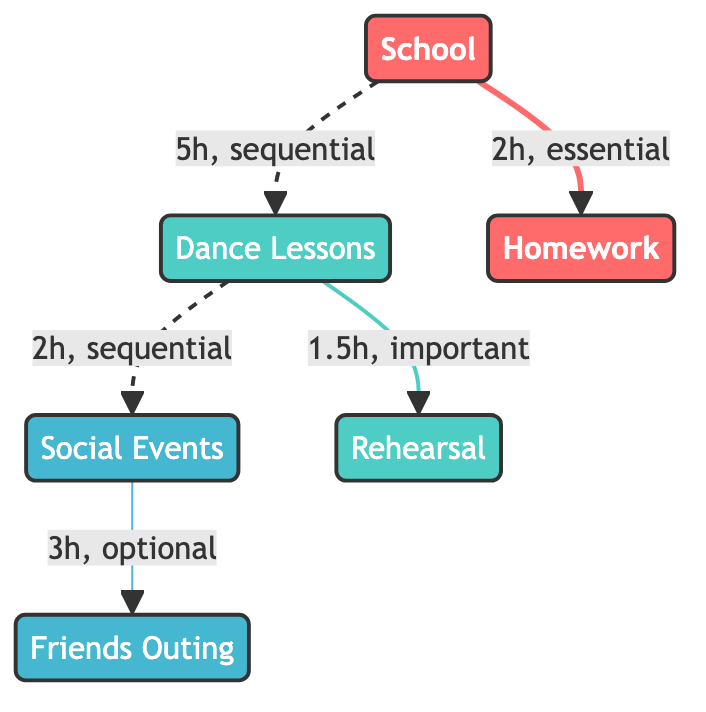What is the priority level of School? The priority level of School is indicated in the node representing it. Here, it is labeled as "high."
Answer: high How much time is spent on homework after school? The link between School and Homework specifies that 2 hours are needed for homework; therefore, the time spent is 2 hours.
Answer: 2 hours What is the connection type between Dance Lessons and Rehearsal? The connection from Dance Lessons to Rehearsal is labeled as "important," as shown in the link description.
Answer: important How many total nodes are represented in the diagram? By counting each unique node in the diagram, we find there are six nodes: School, Dance Lessons, Social Events, Homework, Rehearsal, and Friends Outing.
Answer: 6 What is the time spent on the sequential connection from Dance Lessons to Social Events? The connection from Dance Lessons to Social Events states that it takes 2 hours, confirming the time spent in this sequential connection.
Answer: 2 hours Which activity has the least priority? Among the listed nodes, Social Events is labeled with "low" priority, indicating it has the least priority level compared to others.
Answer: Social Events How many hours are allocated to Dance Lessons in total? The diagram shows two connections involving Dance Lessons: 5 hours to School and 1.5 hours to Rehearsal (after which no further connections were influenced), totaling 6.5 hours.
Answer: 6.5 hours What is the type of the Friends Outing? Friends Outing is classified as a "social" type node in the diagram, which is specified directly on the node itself.
Answer: social Which task is essential and associated with School? Homework is the only task linked to School, denoting that it is essential; this is confirmed by the labeled connection type.
Answer: Homework 